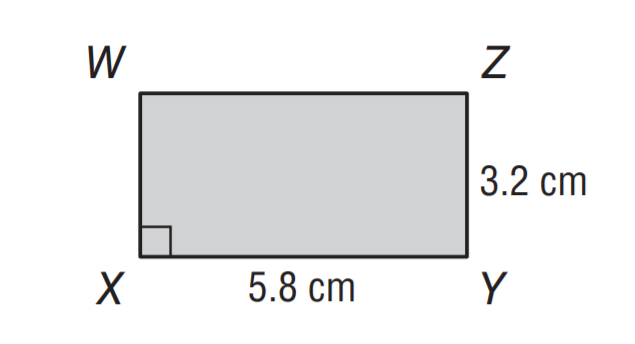Answer the mathemtical geometry problem and directly provide the correct option letter.
Question: What is the area of rectangle W X Y Z?
Choices: A: 18.6 B: 20.4 C: 21.2 D: 22.8 A 